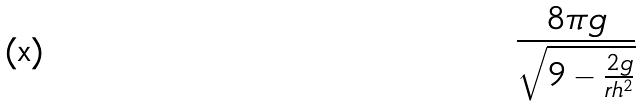Convert formula to latex. <formula><loc_0><loc_0><loc_500><loc_500>\frac { 8 \pi g } { \sqrt { 9 - \frac { 2 g } { r h ^ { 2 } } } }</formula> 